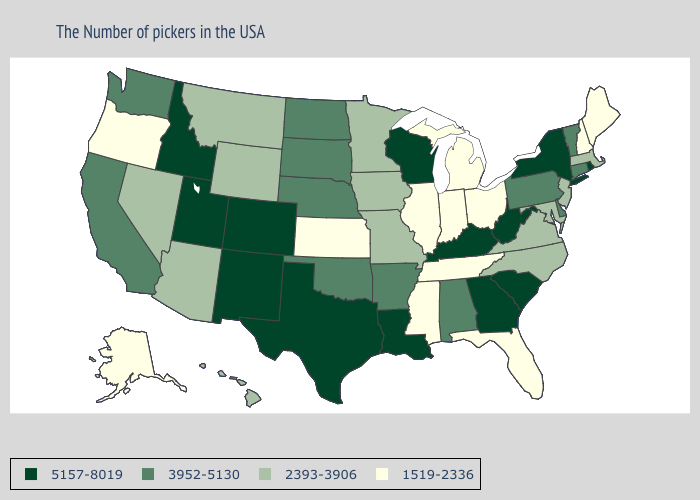What is the value of Kentucky?
Write a very short answer. 5157-8019. Does Utah have a higher value than Oregon?
Short answer required. Yes. What is the highest value in the USA?
Be succinct. 5157-8019. Which states have the highest value in the USA?
Concise answer only. Rhode Island, New York, South Carolina, West Virginia, Georgia, Kentucky, Wisconsin, Louisiana, Texas, Colorado, New Mexico, Utah, Idaho. Does Kansas have the lowest value in the USA?
Quick response, please. Yes. Name the states that have a value in the range 1519-2336?
Give a very brief answer. Maine, New Hampshire, Ohio, Florida, Michigan, Indiana, Tennessee, Illinois, Mississippi, Kansas, Oregon, Alaska. Name the states that have a value in the range 2393-3906?
Be succinct. Massachusetts, New Jersey, Maryland, Virginia, North Carolina, Missouri, Minnesota, Iowa, Wyoming, Montana, Arizona, Nevada, Hawaii. What is the highest value in the USA?
Answer briefly. 5157-8019. Among the states that border New Jersey , does New York have the lowest value?
Answer briefly. No. What is the value of West Virginia?
Concise answer only. 5157-8019. What is the highest value in the West ?
Give a very brief answer. 5157-8019. Which states hav the highest value in the MidWest?
Quick response, please. Wisconsin. What is the value of Georgia?
Quick response, please. 5157-8019. Among the states that border Missouri , does Kansas have the lowest value?
Keep it brief. Yes. Name the states that have a value in the range 5157-8019?
Keep it brief. Rhode Island, New York, South Carolina, West Virginia, Georgia, Kentucky, Wisconsin, Louisiana, Texas, Colorado, New Mexico, Utah, Idaho. 